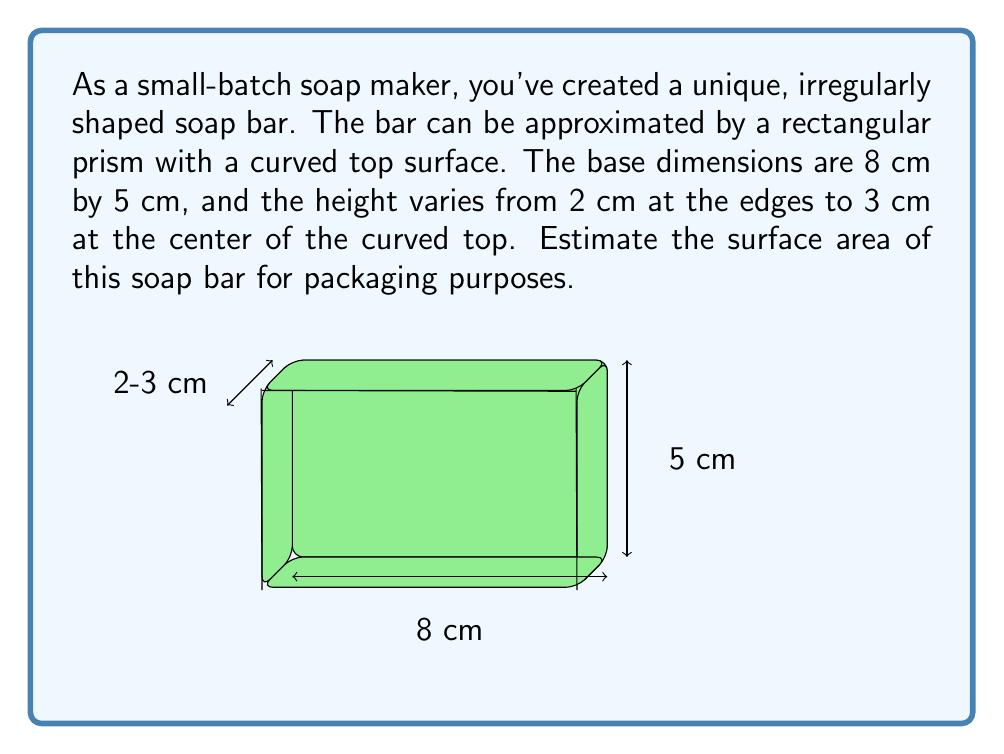Solve this math problem. To estimate the surface area of this irregularly shaped soap bar, we'll break it down into parts:

1) Base area:
   $A_{base} = 8 \text{ cm} \times 5 \text{ cm} = 40 \text{ cm}^2$

2) Side areas (4 rectangular faces):
   Front and back: $A_{front/back} = 2 \times (8 \text{ cm} \times 2.5 \text{ cm}) = 40 \text{ cm}^2$
   Left and right: $A_{left/right} = 2 \times (5 \text{ cm} \times 2.5 \text{ cm}) = 25 \text{ cm}^2$
   Total side area: $A_{sides} = 40 \text{ cm}^2 + 25 \text{ cm}^2 = 65 \text{ cm}^2$

3) Top curved surface:
   To estimate this, we can use the average of the minimum and maximum possible areas:
   Minimum (if flat): $A_{min} = 8 \text{ cm} \times 5 \text{ cm} = 40 \text{ cm}^2$
   Maximum (if hemispheric): $A_{max} \approx 2\pi r^2$, where $r \approx 4.5 \text{ cm}$
   $A_{max} \approx 2\pi(4.5)^2 \approx 127 \text{ cm}^2$
   
   Average top area: $A_{top} = \frac{A_{min} + A_{max}}{2} = \frac{40 + 127}{2} \approx 83.5 \text{ cm}^2$

4) Total estimated surface area:
   $A_{total} = A_{base} + A_{sides} + A_{top}$
   $A_{total} = 40 + 65 + 83.5 = 188.5 \text{ cm}^2$

Therefore, the estimated surface area of the soap bar is approximately 188.5 cm².
Answer: $188.5 \text{ cm}^2$ 